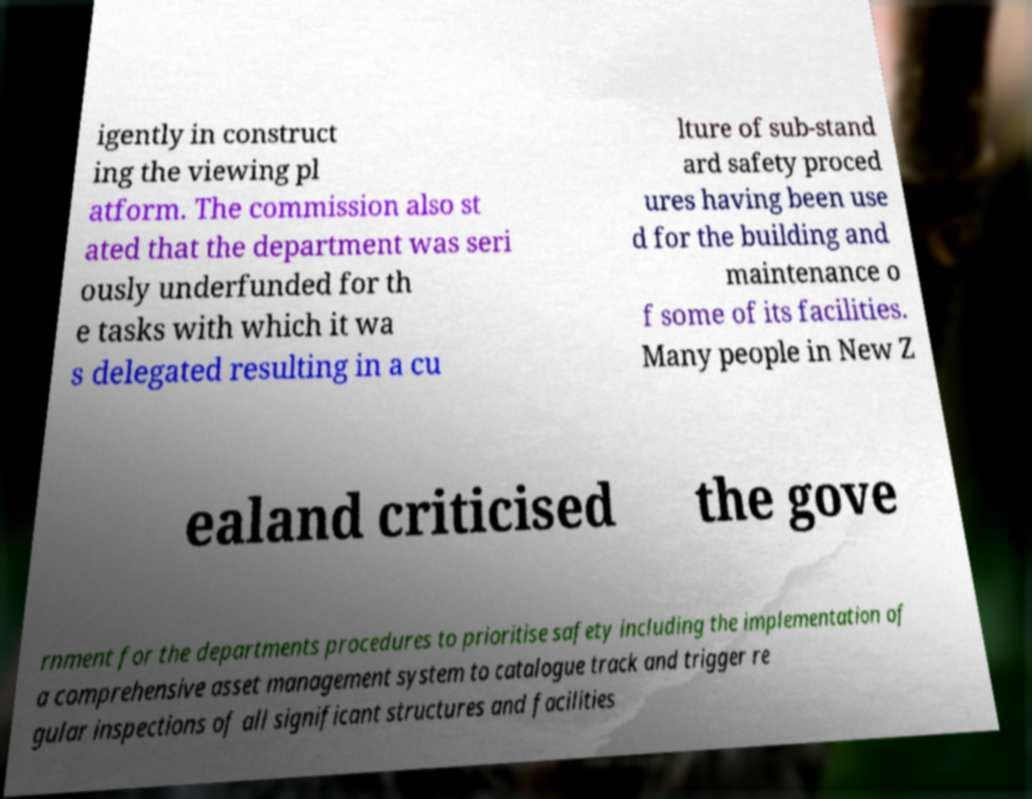There's text embedded in this image that I need extracted. Can you transcribe it verbatim? igently in construct ing the viewing pl atform. The commission also st ated that the department was seri ously underfunded for th e tasks with which it wa s delegated resulting in a cu lture of sub-stand ard safety proced ures having been use d for the building and maintenance o f some of its facilities. Many people in New Z ealand criticised the gove rnment for the departments procedures to prioritise safety including the implementation of a comprehensive asset management system to catalogue track and trigger re gular inspections of all significant structures and facilities 